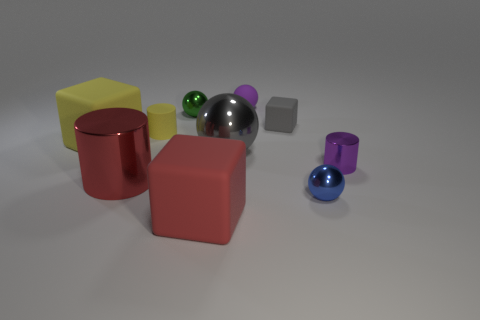Subtract all cylinders. How many objects are left? 7 Subtract all tiny gray objects. Subtract all tiny purple metal cylinders. How many objects are left? 8 Add 1 yellow rubber cylinders. How many yellow rubber cylinders are left? 2 Add 8 big blue cylinders. How many big blue cylinders exist? 8 Subtract 0 red spheres. How many objects are left? 10 